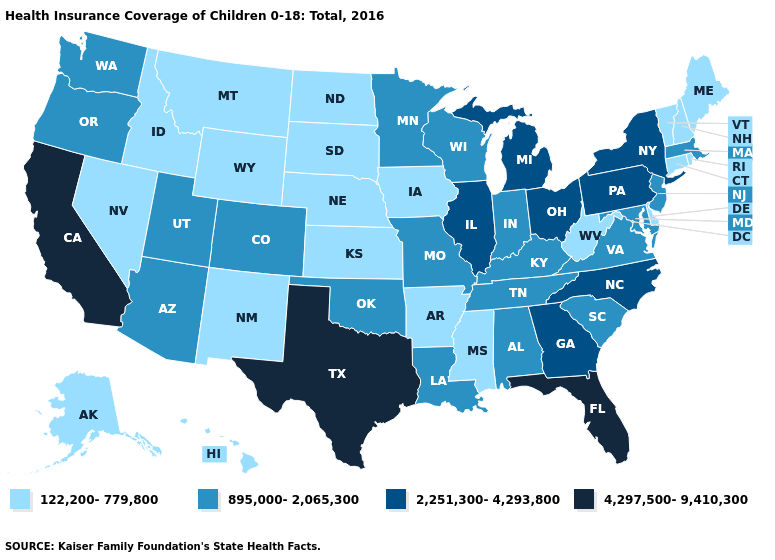Which states have the lowest value in the USA?
Quick response, please. Alaska, Arkansas, Connecticut, Delaware, Hawaii, Idaho, Iowa, Kansas, Maine, Mississippi, Montana, Nebraska, Nevada, New Hampshire, New Mexico, North Dakota, Rhode Island, South Dakota, Vermont, West Virginia, Wyoming. Is the legend a continuous bar?
Keep it brief. No. Which states have the lowest value in the USA?
Write a very short answer. Alaska, Arkansas, Connecticut, Delaware, Hawaii, Idaho, Iowa, Kansas, Maine, Mississippi, Montana, Nebraska, Nevada, New Hampshire, New Mexico, North Dakota, Rhode Island, South Dakota, Vermont, West Virginia, Wyoming. Does Georgia have a lower value than California?
Short answer required. Yes. Which states hav the highest value in the Northeast?
Keep it brief. New York, Pennsylvania. Does Arizona have the highest value in the USA?
Be succinct. No. What is the highest value in the Northeast ?
Be succinct. 2,251,300-4,293,800. Name the states that have a value in the range 895,000-2,065,300?
Write a very short answer. Alabama, Arizona, Colorado, Indiana, Kentucky, Louisiana, Maryland, Massachusetts, Minnesota, Missouri, New Jersey, Oklahoma, Oregon, South Carolina, Tennessee, Utah, Virginia, Washington, Wisconsin. What is the lowest value in the Northeast?
Be succinct. 122,200-779,800. Name the states that have a value in the range 122,200-779,800?
Keep it brief. Alaska, Arkansas, Connecticut, Delaware, Hawaii, Idaho, Iowa, Kansas, Maine, Mississippi, Montana, Nebraska, Nevada, New Hampshire, New Mexico, North Dakota, Rhode Island, South Dakota, Vermont, West Virginia, Wyoming. Name the states that have a value in the range 895,000-2,065,300?
Write a very short answer. Alabama, Arizona, Colorado, Indiana, Kentucky, Louisiana, Maryland, Massachusetts, Minnesota, Missouri, New Jersey, Oklahoma, Oregon, South Carolina, Tennessee, Utah, Virginia, Washington, Wisconsin. Does the map have missing data?
Quick response, please. No. Name the states that have a value in the range 122,200-779,800?
Quick response, please. Alaska, Arkansas, Connecticut, Delaware, Hawaii, Idaho, Iowa, Kansas, Maine, Mississippi, Montana, Nebraska, Nevada, New Hampshire, New Mexico, North Dakota, Rhode Island, South Dakota, Vermont, West Virginia, Wyoming. What is the value of North Carolina?
Short answer required. 2,251,300-4,293,800. What is the value of Iowa?
Answer briefly. 122,200-779,800. 